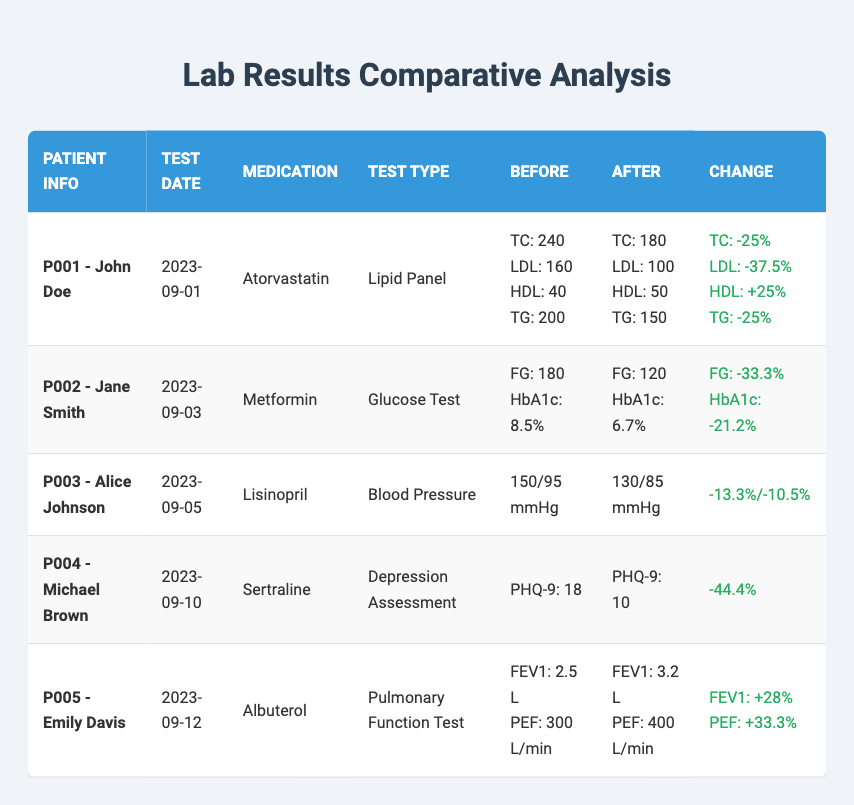What was the total cholesterol level for John Doe before the medication? The table lists John Doe's values under "TotalCholesterol_Before", which shows a value of 240.
Answer: 240 How much did the HDL level change for Emily Davis after the medication? The table provides HDL levels for Emily Davis under "HDL_Before" and "HDL_After". She had 40 before and 50 after, indicating a change of 10.
Answer: 10 Did Jane Smith have a higher Fasting Glucose level before or after taking Metformin? By comparing the "FastingGlucose_Before" value of 180 with the "FastingGlucose_After" value of 120, it is evident that the level was higher before taking the medication.
Answer: Yes What is the percentage decrease in LDL levels for John Doe after taking Atorvastatin? From John Doe's results, we see LDL_Before was 160 and LDL_After is 100. The decrease is calculated as (160 - 100) / 160 * 100 = 37.5%.
Answer: 37.5% Is there any patient who saw a decrease in both FEV1 and PEF levels after medication? The table shows that Emily Davis had increases in both FEV1 and PEF; no other patient’s results indicate a decrease in both after their medication.
Answer: No What was the average change in triglyceride levels across the patients who had lipid panels? Looking at the change in triglycerides only for John Doe (from 200 to 150), it represents a change of 25%. No other patient tested for triglycerides, making the average change from this single record equal to 25%.
Answer: 25% What is the difference in the PHQ-9 scores before and after for Michael Brown? For Michael Brown, the PHQ-9 score was 18 before treatment and 10 after. The difference is calculated as 18 - 10 = 8.
Answer: 8 How many patients experienced an improvement in all metrics after medication? By analyzing the table, all patients saw improvement in their specific metrics (cholesterol, glucose, blood pressure, depression score, and pulmonary function), which indicates that all had improvements.
Answer: All Was there one patient who had a better outcome than others according to their percentage changes? Michael Brown had a -44.4% change in PHQ-9 scores, which is significant compared to others, but improvements varied by metrics making a direct comparison difficult. Thus, one could argue significant improvement depending on metric importance.
Answer: No clear winner 